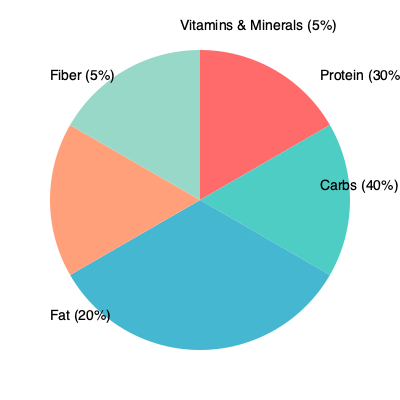As a corporate wellness coordinator, you're designing a balanced meal plan for employees. The pie chart shows the distribution of macronutrients and other components in a proposed meal. If the total caloric content of the meal is 800 calories, how many calories come from protein, and what percentage of the recommended daily protein intake does this represent for an average adult requiring 50 grams of protein per day? To solve this problem, we'll follow these steps:

1. Calculate the calories from protein:
   - Protein represents 30% of the meal
   - Total calories in the meal = 800
   - Calories from protein = $800 \times 0.30 = 240$ calories

2. Convert calories from protein to grams:
   - 1 gram of protein provides 4 calories
   - Grams of protein = $\frac{240 \text{ calories}}{4 \text{ calories/gram}} = 60$ grams

3. Calculate the percentage of daily recommended protein intake:
   - Recommended daily protein intake = 50 grams
   - Percentage of daily intake = $\frac{60 \text{ grams}}{50 \text{ grams}} \times 100\% = 120\%$

Therefore, the meal provides 240 calories from protein, which represents 120% of the recommended daily protein intake for an average adult requiring 50 grams of protein per day.
Answer: 240 calories, 120% of daily recommended intake 